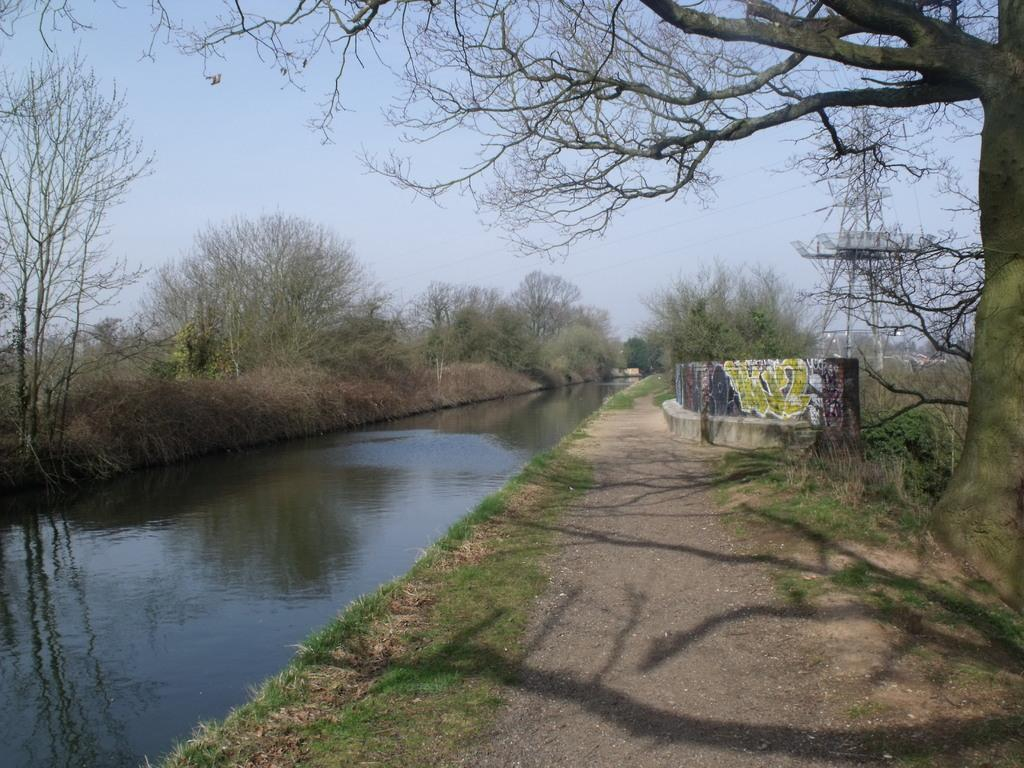What type of vegetation can be seen in the image? There is grass in the image. What type of structure is present in the image? There is a wall in the image. What natural element is visible in the image? There is water visible in the image. What type of plant is present in the image? There are trees in the image. What type of tall structure is present in the image? There is a tower in the image. What man-made objects can be seen in the image? There are wires in the image. What part of the natural environment is visible in the image? The sky is visible in the image. What type of artwork is present on the wall? There is a painting on the wall. What visual effect can be observed in the image? Shadows are present in the image. How many robins are perched on the wires in the image? There are no robins present in the image. What year is depicted in the painting on the wall? The painting on the wall does not depict a specific year. 